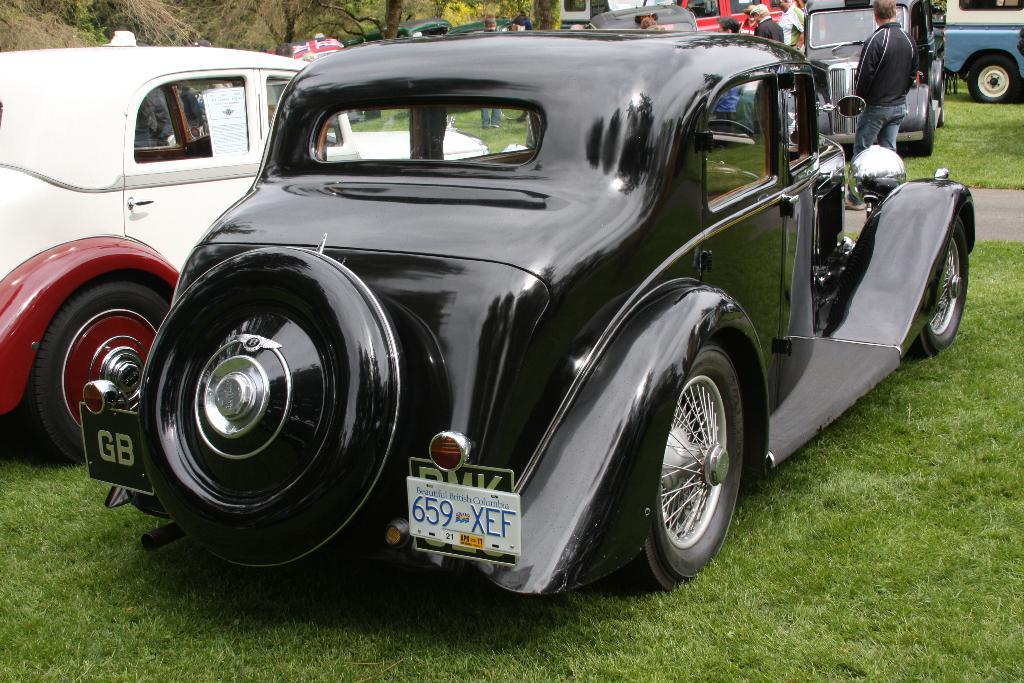What is the main subject of the image? The main subject of the image is many cars. What else can be seen in the image besides the cars? There are trees, a few people, grassy land, and a road in the image. What type of thread is being used to create peace in the image? There is no thread or reference to peace in the image; it primarily features cars, trees, people, grassy land, and a road. 